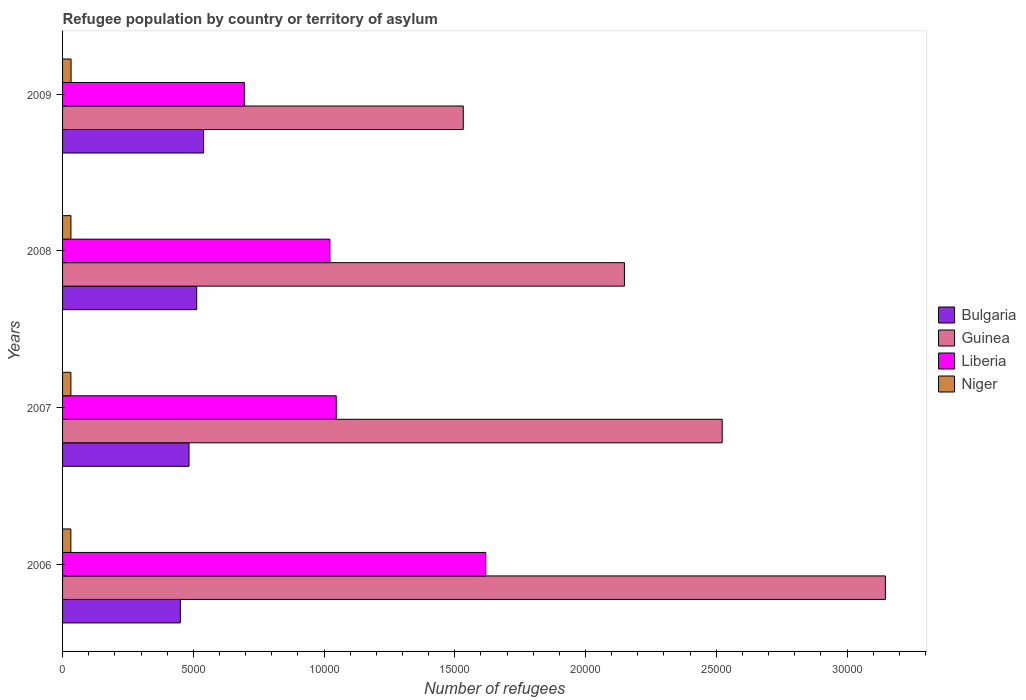Are the number of bars per tick equal to the number of legend labels?
Provide a short and direct response. Yes. Are the number of bars on each tick of the Y-axis equal?
Your response must be concise. Yes. What is the label of the 1st group of bars from the top?
Your answer should be very brief. 2009. What is the number of refugees in Guinea in 2008?
Your answer should be compact. 2.15e+04. Across all years, what is the maximum number of refugees in Guinea?
Give a very brief answer. 3.15e+04. Across all years, what is the minimum number of refugees in Liberia?
Your answer should be very brief. 6952. In which year was the number of refugees in Liberia maximum?
Your response must be concise. 2006. In which year was the number of refugees in Niger minimum?
Offer a terse response. 2006. What is the total number of refugees in Liberia in the graph?
Offer a terse response. 4.38e+04. What is the difference between the number of refugees in Guinea in 2008 and that in 2009?
Offer a very short reply. 6163. What is the difference between the number of refugees in Niger in 2006 and the number of refugees in Bulgaria in 2009?
Your answer should be compact. -5076. What is the average number of refugees in Guinea per year?
Provide a short and direct response. 2.34e+04. In the year 2009, what is the difference between the number of refugees in Liberia and number of refugees in Guinea?
Your answer should be very brief. -8373. In how many years, is the number of refugees in Guinea greater than 29000 ?
Ensure brevity in your answer.  1. What is the ratio of the number of refugees in Niger in 2007 to that in 2009?
Your response must be concise. 0.98. What is the difference between the highest and the second highest number of refugees in Bulgaria?
Ensure brevity in your answer.  264. What is the difference between the highest and the lowest number of refugees in Bulgaria?
Offer a very short reply. 889. In how many years, is the number of refugees in Liberia greater than the average number of refugees in Liberia taken over all years?
Your answer should be compact. 1. Is it the case that in every year, the sum of the number of refugees in Guinea and number of refugees in Liberia is greater than the sum of number of refugees in Bulgaria and number of refugees in Niger?
Make the answer very short. No. What does the 2nd bar from the top in 2009 represents?
Provide a short and direct response. Liberia. What does the 2nd bar from the bottom in 2006 represents?
Offer a very short reply. Guinea. How many bars are there?
Make the answer very short. 16. How many years are there in the graph?
Your answer should be very brief. 4. Does the graph contain grids?
Your answer should be compact. No. Where does the legend appear in the graph?
Offer a terse response. Center right. How many legend labels are there?
Your answer should be compact. 4. How are the legend labels stacked?
Offer a terse response. Vertical. What is the title of the graph?
Offer a very short reply. Refugee population by country or territory of asylum. Does "Germany" appear as one of the legend labels in the graph?
Offer a very short reply. No. What is the label or title of the X-axis?
Your answer should be compact. Number of refugees. What is the Number of refugees in Bulgaria in 2006?
Provide a succinct answer. 4504. What is the Number of refugees in Guinea in 2006?
Your response must be concise. 3.15e+04. What is the Number of refugees in Liberia in 2006?
Ensure brevity in your answer.  1.62e+04. What is the Number of refugees of Niger in 2006?
Offer a very short reply. 317. What is the Number of refugees of Bulgaria in 2007?
Ensure brevity in your answer.  4836. What is the Number of refugees of Guinea in 2007?
Offer a terse response. 2.52e+04. What is the Number of refugees in Liberia in 2007?
Make the answer very short. 1.05e+04. What is the Number of refugees of Niger in 2007?
Your answer should be compact. 319. What is the Number of refugees in Bulgaria in 2008?
Provide a short and direct response. 5129. What is the Number of refugees of Guinea in 2008?
Your answer should be very brief. 2.15e+04. What is the Number of refugees in Liberia in 2008?
Your answer should be very brief. 1.02e+04. What is the Number of refugees of Niger in 2008?
Give a very brief answer. 320. What is the Number of refugees in Bulgaria in 2009?
Give a very brief answer. 5393. What is the Number of refugees of Guinea in 2009?
Your answer should be very brief. 1.53e+04. What is the Number of refugees of Liberia in 2009?
Offer a very short reply. 6952. What is the Number of refugees of Niger in 2009?
Offer a very short reply. 325. Across all years, what is the maximum Number of refugees in Bulgaria?
Provide a short and direct response. 5393. Across all years, what is the maximum Number of refugees of Guinea?
Provide a short and direct response. 3.15e+04. Across all years, what is the maximum Number of refugees of Liberia?
Offer a very short reply. 1.62e+04. Across all years, what is the maximum Number of refugees of Niger?
Your answer should be compact. 325. Across all years, what is the minimum Number of refugees of Bulgaria?
Provide a short and direct response. 4504. Across all years, what is the minimum Number of refugees in Guinea?
Ensure brevity in your answer.  1.53e+04. Across all years, what is the minimum Number of refugees in Liberia?
Keep it short and to the point. 6952. Across all years, what is the minimum Number of refugees in Niger?
Your answer should be very brief. 317. What is the total Number of refugees in Bulgaria in the graph?
Ensure brevity in your answer.  1.99e+04. What is the total Number of refugees of Guinea in the graph?
Your response must be concise. 9.35e+04. What is the total Number of refugees of Liberia in the graph?
Give a very brief answer. 4.38e+04. What is the total Number of refugees in Niger in the graph?
Make the answer very short. 1281. What is the difference between the Number of refugees of Bulgaria in 2006 and that in 2007?
Keep it short and to the point. -332. What is the difference between the Number of refugees of Guinea in 2006 and that in 2007?
Give a very brief answer. 6242. What is the difference between the Number of refugees of Liberia in 2006 and that in 2007?
Keep it short and to the point. 5719. What is the difference between the Number of refugees in Bulgaria in 2006 and that in 2008?
Your response must be concise. -625. What is the difference between the Number of refugees of Guinea in 2006 and that in 2008?
Offer a very short reply. 9980. What is the difference between the Number of refugees of Liberia in 2006 and that in 2008?
Your response must be concise. 5961. What is the difference between the Number of refugees in Bulgaria in 2006 and that in 2009?
Provide a succinct answer. -889. What is the difference between the Number of refugees in Guinea in 2006 and that in 2009?
Your response must be concise. 1.61e+04. What is the difference between the Number of refugees in Liberia in 2006 and that in 2009?
Keep it short and to the point. 9233. What is the difference between the Number of refugees of Bulgaria in 2007 and that in 2008?
Provide a succinct answer. -293. What is the difference between the Number of refugees of Guinea in 2007 and that in 2008?
Your response must be concise. 3738. What is the difference between the Number of refugees of Liberia in 2007 and that in 2008?
Your answer should be very brief. 242. What is the difference between the Number of refugees of Niger in 2007 and that in 2008?
Offer a terse response. -1. What is the difference between the Number of refugees in Bulgaria in 2007 and that in 2009?
Offer a terse response. -557. What is the difference between the Number of refugees in Guinea in 2007 and that in 2009?
Your answer should be compact. 9901. What is the difference between the Number of refugees in Liberia in 2007 and that in 2009?
Your answer should be very brief. 3514. What is the difference between the Number of refugees of Bulgaria in 2008 and that in 2009?
Your answer should be very brief. -264. What is the difference between the Number of refugees of Guinea in 2008 and that in 2009?
Provide a short and direct response. 6163. What is the difference between the Number of refugees in Liberia in 2008 and that in 2009?
Make the answer very short. 3272. What is the difference between the Number of refugees in Niger in 2008 and that in 2009?
Provide a short and direct response. -5. What is the difference between the Number of refugees in Bulgaria in 2006 and the Number of refugees in Guinea in 2007?
Provide a succinct answer. -2.07e+04. What is the difference between the Number of refugees of Bulgaria in 2006 and the Number of refugees of Liberia in 2007?
Ensure brevity in your answer.  -5962. What is the difference between the Number of refugees in Bulgaria in 2006 and the Number of refugees in Niger in 2007?
Offer a terse response. 4185. What is the difference between the Number of refugees in Guinea in 2006 and the Number of refugees in Liberia in 2007?
Give a very brief answer. 2.10e+04. What is the difference between the Number of refugees of Guinea in 2006 and the Number of refugees of Niger in 2007?
Make the answer very short. 3.11e+04. What is the difference between the Number of refugees in Liberia in 2006 and the Number of refugees in Niger in 2007?
Offer a very short reply. 1.59e+04. What is the difference between the Number of refugees of Bulgaria in 2006 and the Number of refugees of Guinea in 2008?
Ensure brevity in your answer.  -1.70e+04. What is the difference between the Number of refugees of Bulgaria in 2006 and the Number of refugees of Liberia in 2008?
Offer a terse response. -5720. What is the difference between the Number of refugees in Bulgaria in 2006 and the Number of refugees in Niger in 2008?
Your answer should be compact. 4184. What is the difference between the Number of refugees of Guinea in 2006 and the Number of refugees of Liberia in 2008?
Make the answer very short. 2.12e+04. What is the difference between the Number of refugees in Guinea in 2006 and the Number of refugees in Niger in 2008?
Your answer should be very brief. 3.11e+04. What is the difference between the Number of refugees in Liberia in 2006 and the Number of refugees in Niger in 2008?
Your answer should be very brief. 1.59e+04. What is the difference between the Number of refugees in Bulgaria in 2006 and the Number of refugees in Guinea in 2009?
Offer a terse response. -1.08e+04. What is the difference between the Number of refugees in Bulgaria in 2006 and the Number of refugees in Liberia in 2009?
Your answer should be very brief. -2448. What is the difference between the Number of refugees in Bulgaria in 2006 and the Number of refugees in Niger in 2009?
Your answer should be compact. 4179. What is the difference between the Number of refugees of Guinea in 2006 and the Number of refugees of Liberia in 2009?
Give a very brief answer. 2.45e+04. What is the difference between the Number of refugees in Guinea in 2006 and the Number of refugees in Niger in 2009?
Your answer should be very brief. 3.11e+04. What is the difference between the Number of refugees of Liberia in 2006 and the Number of refugees of Niger in 2009?
Provide a short and direct response. 1.59e+04. What is the difference between the Number of refugees in Bulgaria in 2007 and the Number of refugees in Guinea in 2008?
Give a very brief answer. -1.67e+04. What is the difference between the Number of refugees of Bulgaria in 2007 and the Number of refugees of Liberia in 2008?
Provide a succinct answer. -5388. What is the difference between the Number of refugees of Bulgaria in 2007 and the Number of refugees of Niger in 2008?
Your response must be concise. 4516. What is the difference between the Number of refugees of Guinea in 2007 and the Number of refugees of Liberia in 2008?
Ensure brevity in your answer.  1.50e+04. What is the difference between the Number of refugees in Guinea in 2007 and the Number of refugees in Niger in 2008?
Offer a terse response. 2.49e+04. What is the difference between the Number of refugees in Liberia in 2007 and the Number of refugees in Niger in 2008?
Offer a terse response. 1.01e+04. What is the difference between the Number of refugees in Bulgaria in 2007 and the Number of refugees in Guinea in 2009?
Your answer should be compact. -1.05e+04. What is the difference between the Number of refugees in Bulgaria in 2007 and the Number of refugees in Liberia in 2009?
Provide a succinct answer. -2116. What is the difference between the Number of refugees of Bulgaria in 2007 and the Number of refugees of Niger in 2009?
Your answer should be very brief. 4511. What is the difference between the Number of refugees in Guinea in 2007 and the Number of refugees in Liberia in 2009?
Your response must be concise. 1.83e+04. What is the difference between the Number of refugees of Guinea in 2007 and the Number of refugees of Niger in 2009?
Make the answer very short. 2.49e+04. What is the difference between the Number of refugees of Liberia in 2007 and the Number of refugees of Niger in 2009?
Provide a short and direct response. 1.01e+04. What is the difference between the Number of refugees of Bulgaria in 2008 and the Number of refugees of Guinea in 2009?
Give a very brief answer. -1.02e+04. What is the difference between the Number of refugees in Bulgaria in 2008 and the Number of refugees in Liberia in 2009?
Provide a succinct answer. -1823. What is the difference between the Number of refugees in Bulgaria in 2008 and the Number of refugees in Niger in 2009?
Your response must be concise. 4804. What is the difference between the Number of refugees in Guinea in 2008 and the Number of refugees in Liberia in 2009?
Keep it short and to the point. 1.45e+04. What is the difference between the Number of refugees in Guinea in 2008 and the Number of refugees in Niger in 2009?
Your answer should be compact. 2.12e+04. What is the difference between the Number of refugees of Liberia in 2008 and the Number of refugees of Niger in 2009?
Your answer should be very brief. 9899. What is the average Number of refugees in Bulgaria per year?
Keep it short and to the point. 4965.5. What is the average Number of refugees of Guinea per year?
Make the answer very short. 2.34e+04. What is the average Number of refugees of Liberia per year?
Give a very brief answer. 1.10e+04. What is the average Number of refugees of Niger per year?
Your response must be concise. 320.25. In the year 2006, what is the difference between the Number of refugees in Bulgaria and Number of refugees in Guinea?
Provide a short and direct response. -2.70e+04. In the year 2006, what is the difference between the Number of refugees of Bulgaria and Number of refugees of Liberia?
Give a very brief answer. -1.17e+04. In the year 2006, what is the difference between the Number of refugees in Bulgaria and Number of refugees in Niger?
Your answer should be very brief. 4187. In the year 2006, what is the difference between the Number of refugees in Guinea and Number of refugees in Liberia?
Your answer should be very brief. 1.53e+04. In the year 2006, what is the difference between the Number of refugees in Guinea and Number of refugees in Niger?
Ensure brevity in your answer.  3.12e+04. In the year 2006, what is the difference between the Number of refugees in Liberia and Number of refugees in Niger?
Your answer should be compact. 1.59e+04. In the year 2007, what is the difference between the Number of refugees in Bulgaria and Number of refugees in Guinea?
Make the answer very short. -2.04e+04. In the year 2007, what is the difference between the Number of refugees in Bulgaria and Number of refugees in Liberia?
Your response must be concise. -5630. In the year 2007, what is the difference between the Number of refugees of Bulgaria and Number of refugees of Niger?
Make the answer very short. 4517. In the year 2007, what is the difference between the Number of refugees of Guinea and Number of refugees of Liberia?
Offer a terse response. 1.48e+04. In the year 2007, what is the difference between the Number of refugees in Guinea and Number of refugees in Niger?
Your answer should be very brief. 2.49e+04. In the year 2007, what is the difference between the Number of refugees of Liberia and Number of refugees of Niger?
Provide a succinct answer. 1.01e+04. In the year 2008, what is the difference between the Number of refugees in Bulgaria and Number of refugees in Guinea?
Your answer should be compact. -1.64e+04. In the year 2008, what is the difference between the Number of refugees of Bulgaria and Number of refugees of Liberia?
Make the answer very short. -5095. In the year 2008, what is the difference between the Number of refugees of Bulgaria and Number of refugees of Niger?
Make the answer very short. 4809. In the year 2008, what is the difference between the Number of refugees in Guinea and Number of refugees in Liberia?
Offer a very short reply. 1.13e+04. In the year 2008, what is the difference between the Number of refugees in Guinea and Number of refugees in Niger?
Offer a very short reply. 2.12e+04. In the year 2008, what is the difference between the Number of refugees in Liberia and Number of refugees in Niger?
Your answer should be very brief. 9904. In the year 2009, what is the difference between the Number of refugees in Bulgaria and Number of refugees in Guinea?
Ensure brevity in your answer.  -9932. In the year 2009, what is the difference between the Number of refugees in Bulgaria and Number of refugees in Liberia?
Give a very brief answer. -1559. In the year 2009, what is the difference between the Number of refugees in Bulgaria and Number of refugees in Niger?
Offer a very short reply. 5068. In the year 2009, what is the difference between the Number of refugees in Guinea and Number of refugees in Liberia?
Make the answer very short. 8373. In the year 2009, what is the difference between the Number of refugees in Guinea and Number of refugees in Niger?
Keep it short and to the point. 1.50e+04. In the year 2009, what is the difference between the Number of refugees in Liberia and Number of refugees in Niger?
Offer a very short reply. 6627. What is the ratio of the Number of refugees in Bulgaria in 2006 to that in 2007?
Keep it short and to the point. 0.93. What is the ratio of the Number of refugees in Guinea in 2006 to that in 2007?
Provide a short and direct response. 1.25. What is the ratio of the Number of refugees of Liberia in 2006 to that in 2007?
Offer a terse response. 1.55. What is the ratio of the Number of refugees of Bulgaria in 2006 to that in 2008?
Provide a succinct answer. 0.88. What is the ratio of the Number of refugees in Guinea in 2006 to that in 2008?
Provide a short and direct response. 1.46. What is the ratio of the Number of refugees in Liberia in 2006 to that in 2008?
Keep it short and to the point. 1.58. What is the ratio of the Number of refugees of Niger in 2006 to that in 2008?
Your answer should be compact. 0.99. What is the ratio of the Number of refugees in Bulgaria in 2006 to that in 2009?
Give a very brief answer. 0.84. What is the ratio of the Number of refugees of Guinea in 2006 to that in 2009?
Provide a succinct answer. 2.05. What is the ratio of the Number of refugees of Liberia in 2006 to that in 2009?
Your answer should be compact. 2.33. What is the ratio of the Number of refugees in Niger in 2006 to that in 2009?
Keep it short and to the point. 0.98. What is the ratio of the Number of refugees in Bulgaria in 2007 to that in 2008?
Provide a succinct answer. 0.94. What is the ratio of the Number of refugees in Guinea in 2007 to that in 2008?
Ensure brevity in your answer.  1.17. What is the ratio of the Number of refugees of Liberia in 2007 to that in 2008?
Keep it short and to the point. 1.02. What is the ratio of the Number of refugees of Niger in 2007 to that in 2008?
Provide a short and direct response. 1. What is the ratio of the Number of refugees in Bulgaria in 2007 to that in 2009?
Provide a short and direct response. 0.9. What is the ratio of the Number of refugees of Guinea in 2007 to that in 2009?
Give a very brief answer. 1.65. What is the ratio of the Number of refugees of Liberia in 2007 to that in 2009?
Provide a short and direct response. 1.51. What is the ratio of the Number of refugees of Niger in 2007 to that in 2009?
Offer a very short reply. 0.98. What is the ratio of the Number of refugees in Bulgaria in 2008 to that in 2009?
Give a very brief answer. 0.95. What is the ratio of the Number of refugees in Guinea in 2008 to that in 2009?
Give a very brief answer. 1.4. What is the ratio of the Number of refugees of Liberia in 2008 to that in 2009?
Offer a very short reply. 1.47. What is the ratio of the Number of refugees of Niger in 2008 to that in 2009?
Ensure brevity in your answer.  0.98. What is the difference between the highest and the second highest Number of refugees of Bulgaria?
Your answer should be very brief. 264. What is the difference between the highest and the second highest Number of refugees of Guinea?
Provide a succinct answer. 6242. What is the difference between the highest and the second highest Number of refugees of Liberia?
Provide a short and direct response. 5719. What is the difference between the highest and the lowest Number of refugees in Bulgaria?
Keep it short and to the point. 889. What is the difference between the highest and the lowest Number of refugees in Guinea?
Your answer should be compact. 1.61e+04. What is the difference between the highest and the lowest Number of refugees of Liberia?
Keep it short and to the point. 9233. 